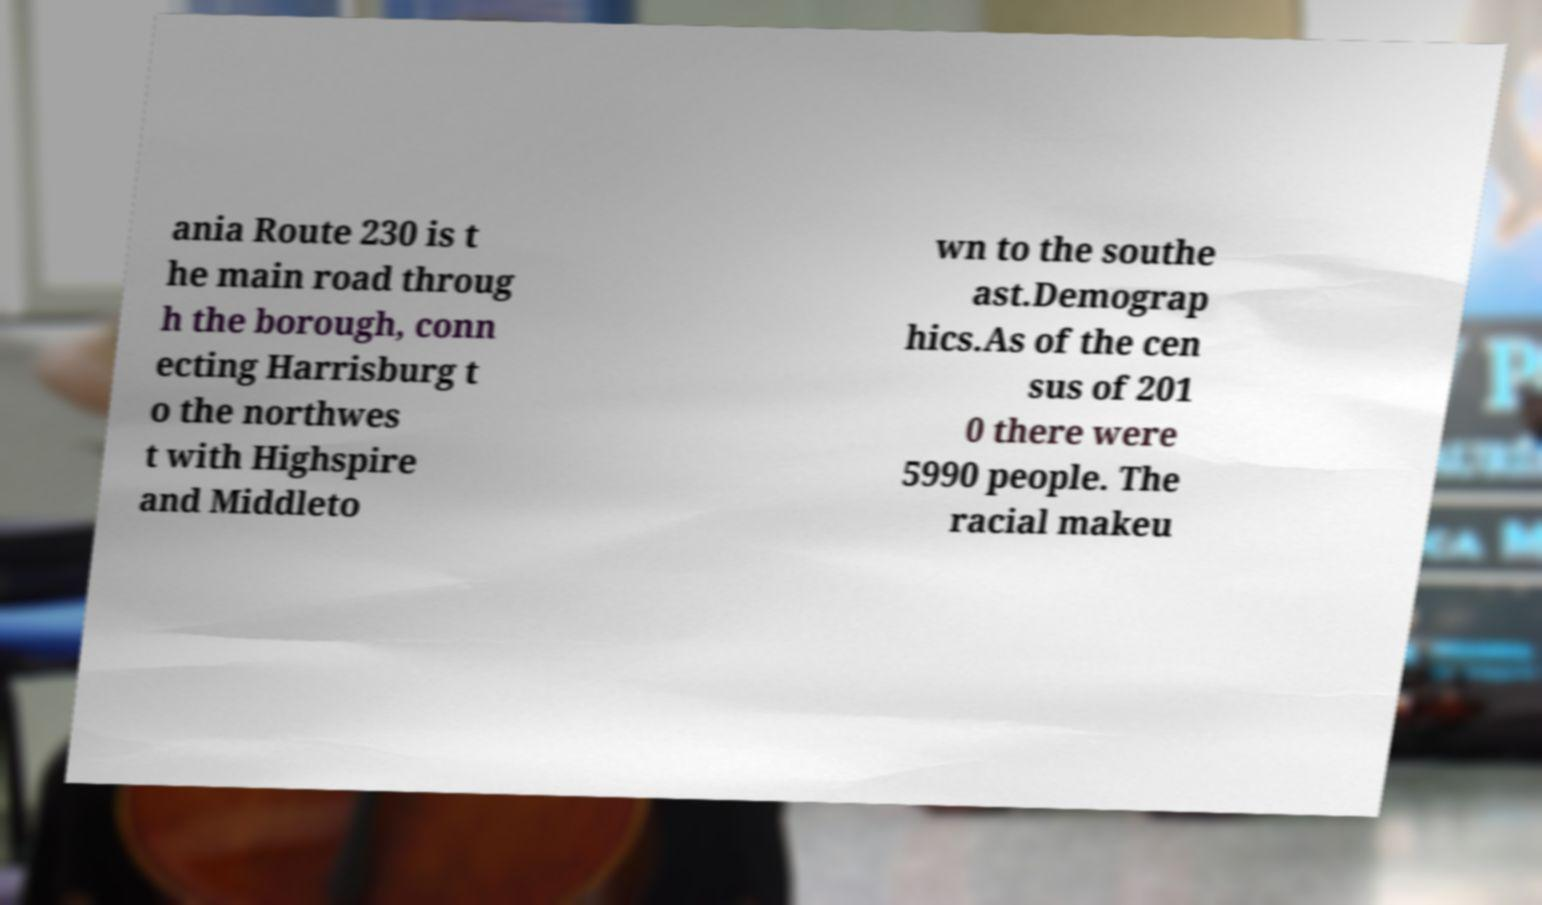Can you read and provide the text displayed in the image?This photo seems to have some interesting text. Can you extract and type it out for me? ania Route 230 is t he main road throug h the borough, conn ecting Harrisburg t o the northwes t with Highspire and Middleto wn to the southe ast.Demograp hics.As of the cen sus of 201 0 there were 5990 people. The racial makeu 